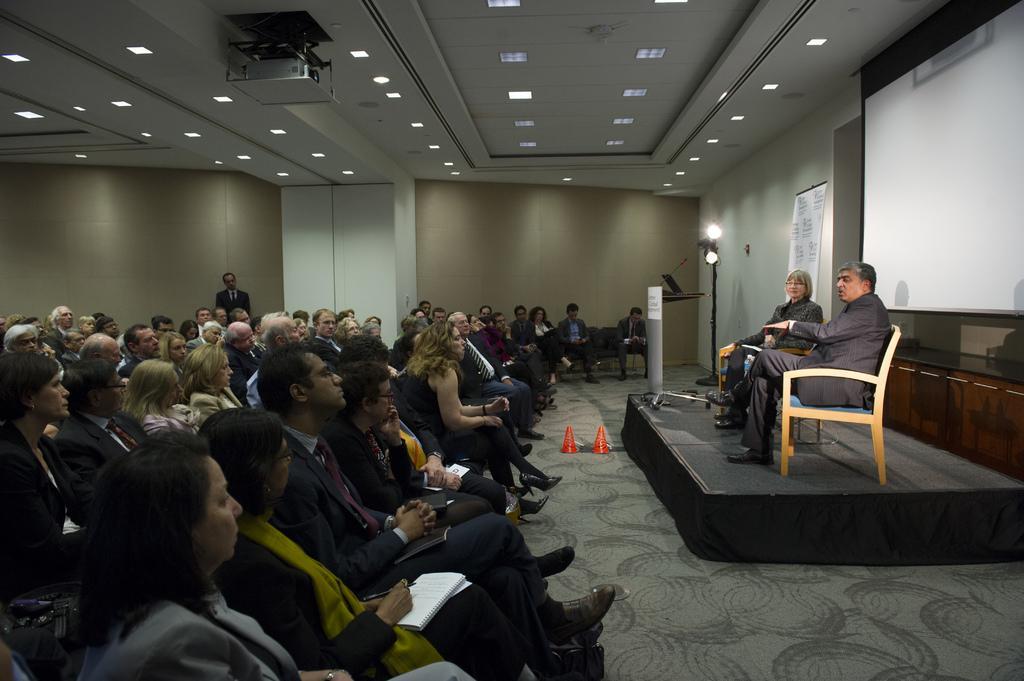Describe this image in one or two sentences. In this image i can see a large number of people sitting and in the background i can see a person standing, a wall, a projector and some lights to the ceiling. 